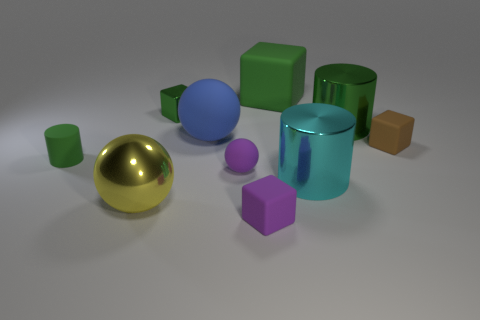Subtract all cyan blocks. Subtract all brown cylinders. How many blocks are left? 4 Subtract all blocks. How many objects are left? 6 Subtract 0 brown spheres. How many objects are left? 10 Subtract all cyan shiny things. Subtract all cyan cylinders. How many objects are left? 8 Add 6 tiny purple cubes. How many tiny purple cubes are left? 7 Add 8 large cyan metal objects. How many large cyan metal objects exist? 9 